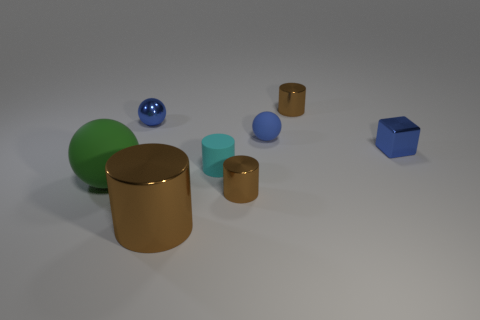There is a thing that is both in front of the tiny metal sphere and to the right of the tiny blue rubber object; what is its color?
Your response must be concise. Blue. How big is the cyan cylinder?
Ensure brevity in your answer.  Small. There is a metallic cylinder that is behind the blue rubber thing; is its color the same as the small metal sphere?
Your response must be concise. No. Is the number of large metallic cylinders to the left of the green rubber thing greater than the number of blue matte spheres that are on the left side of the matte cylinder?
Your answer should be very brief. No. Is the number of tiny purple metallic cubes greater than the number of blue cubes?
Offer a terse response. No. How big is the metal object that is left of the tiny matte cylinder and behind the big green matte object?
Make the answer very short. Small. What shape is the green thing?
Offer a terse response. Sphere. Is there any other thing that is the same size as the blue metal block?
Your answer should be very brief. Yes. Is the number of tiny shiny cylinders behind the large green ball greater than the number of small blue cubes?
Provide a short and direct response. No. What is the shape of the blue thing that is behind the blue ball that is to the right of the big thing to the right of the green matte object?
Give a very brief answer. Sphere. 